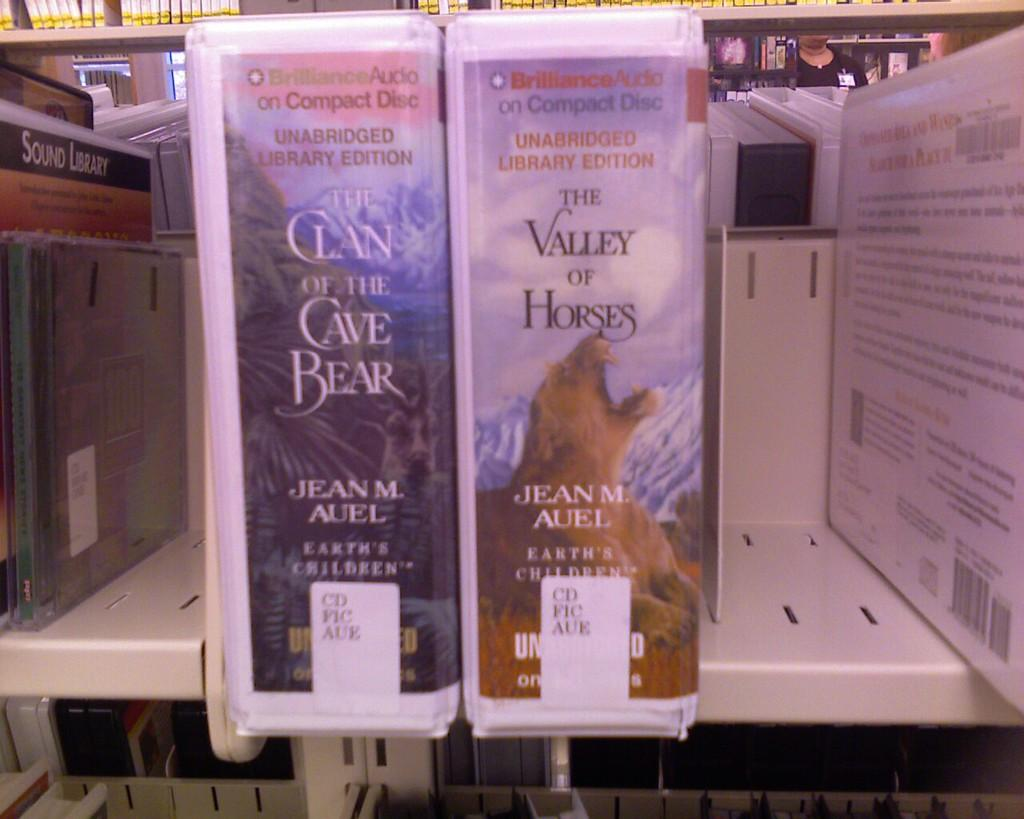Provide a one-sentence caption for the provided image. Two compact disc recordings of novels by Jean M. Auel sit side by side on a shelf. 